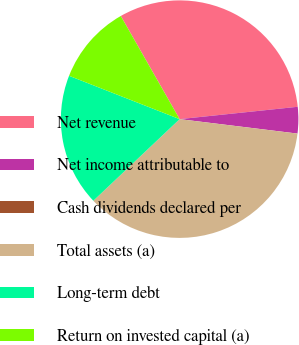Convert chart to OTSL. <chart><loc_0><loc_0><loc_500><loc_500><pie_chart><fcel>Net revenue<fcel>Net income attributable to<fcel>Cash dividends declared per<fcel>Total assets (a)<fcel>Long-term debt<fcel>Return on invested capital (a)<nl><fcel>31.59%<fcel>3.6%<fcel>0.0%<fcel>36.0%<fcel>18.0%<fcel>10.8%<nl></chart> 